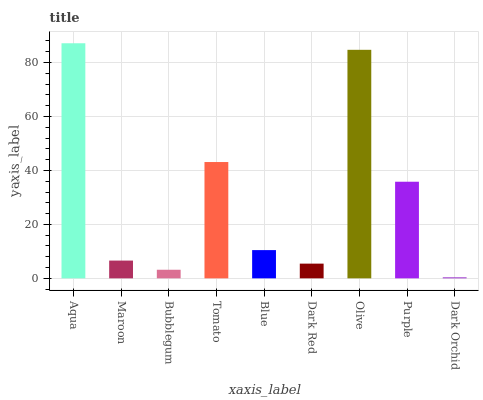Is Dark Orchid the minimum?
Answer yes or no. Yes. Is Aqua the maximum?
Answer yes or no. Yes. Is Maroon the minimum?
Answer yes or no. No. Is Maroon the maximum?
Answer yes or no. No. Is Aqua greater than Maroon?
Answer yes or no. Yes. Is Maroon less than Aqua?
Answer yes or no. Yes. Is Maroon greater than Aqua?
Answer yes or no. No. Is Aqua less than Maroon?
Answer yes or no. No. Is Blue the high median?
Answer yes or no. Yes. Is Blue the low median?
Answer yes or no. Yes. Is Maroon the high median?
Answer yes or no. No. Is Dark Red the low median?
Answer yes or no. No. 